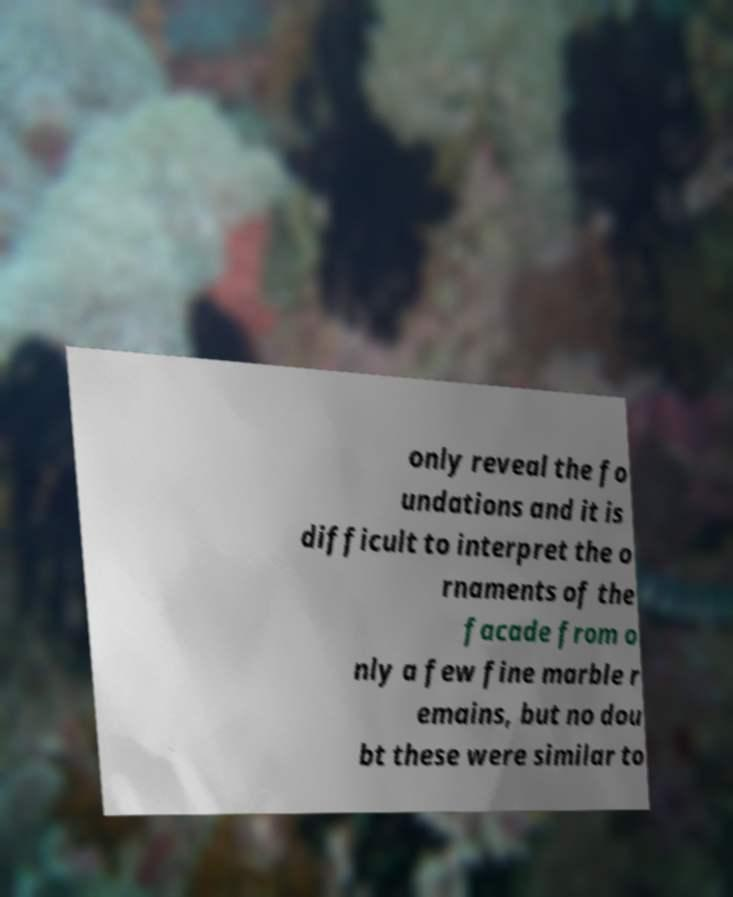Can you read and provide the text displayed in the image?This photo seems to have some interesting text. Can you extract and type it out for me? only reveal the fo undations and it is difficult to interpret the o rnaments of the facade from o nly a few fine marble r emains, but no dou bt these were similar to 